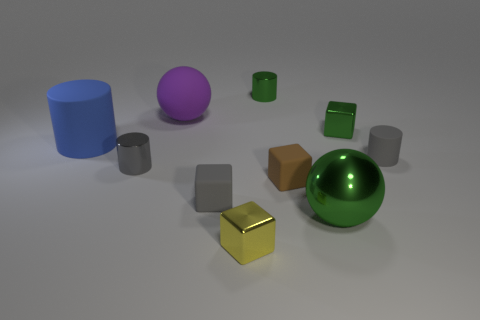Are there any green things that are to the left of the rubber thing that is to the right of the tiny brown rubber thing?
Make the answer very short. Yes. There is a small cube that is in front of the big blue matte thing and right of the tiny green cylinder; what color is it?
Your answer should be compact. Brown. There is a shiny cylinder that is behind the cylinder that is on the right side of the tiny brown object; is there a tiny green metal thing that is in front of it?
Provide a short and direct response. Yes. The green metal thing that is the same shape as the big blue thing is what size?
Keep it short and to the point. Small. Are any gray rubber cylinders visible?
Offer a terse response. Yes. Does the large matte cylinder have the same color as the metal cylinder that is left of the yellow thing?
Offer a very short reply. No. What size is the purple sphere to the left of the tiny shiny thing in front of the gray cylinder on the left side of the green metal sphere?
Your answer should be very brief. Large. How many tiny shiny cubes are the same color as the large rubber sphere?
Offer a very short reply. 0. What number of things are tiny brown cubes or objects to the right of the purple sphere?
Your answer should be very brief. 7. What color is the large cylinder?
Ensure brevity in your answer.  Blue. 